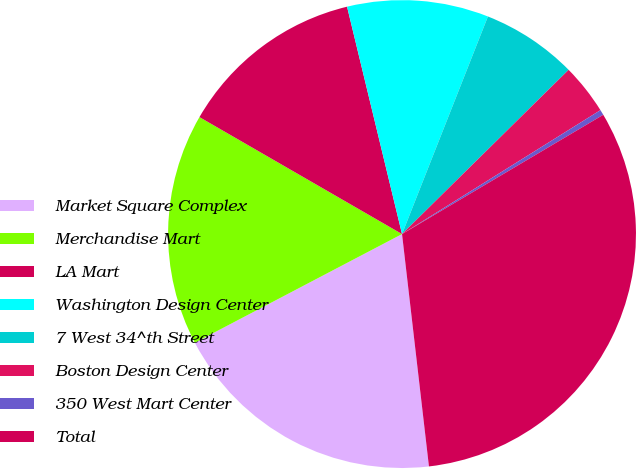Convert chart to OTSL. <chart><loc_0><loc_0><loc_500><loc_500><pie_chart><fcel>Market Square Complex<fcel>Merchandise Mart<fcel>LA Mart<fcel>Washington Design Center<fcel>7 West 34^th Street<fcel>Boston Design Center<fcel>350 West Mart Center<fcel>Total<nl><fcel>19.15%<fcel>16.02%<fcel>12.89%<fcel>9.76%<fcel>6.63%<fcel>3.5%<fcel>0.37%<fcel>31.68%<nl></chart> 